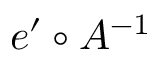Convert formula to latex. <formula><loc_0><loc_0><loc_500><loc_500>e ^ { \prime } \circ A ^ { - 1 }</formula> 